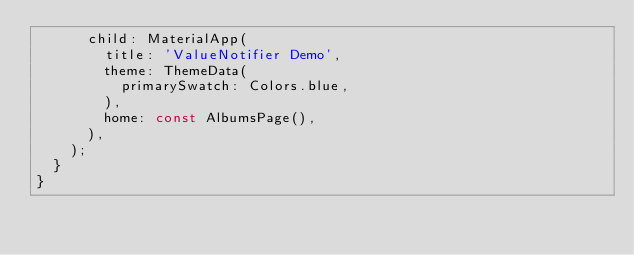Convert code to text. <code><loc_0><loc_0><loc_500><loc_500><_Dart_>      child: MaterialApp(
        title: 'ValueNotifier Demo',
        theme: ThemeData(
          primarySwatch: Colors.blue,
        ),
        home: const AlbumsPage(),
      ),
    );
  }
}
</code> 